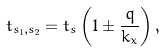<formula> <loc_0><loc_0><loc_500><loc_500>t _ { s _ { 1 } , s _ { 2 } } = t _ { s } \left ( 1 \pm \frac { q } { k _ { x } } \right ) ,</formula> 